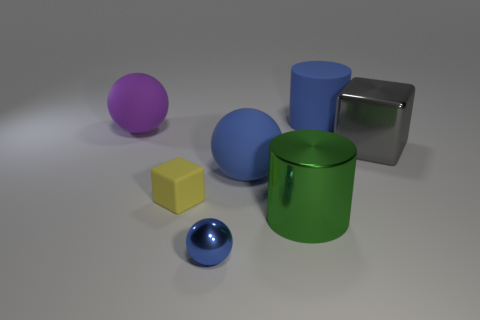Could you infer the function or purpose of each object depicted? The objects seem to be simplistic representations often used in visual or physical simulations and lack any specific features that would indicate a complex function. The green container and blue cylinder may serve as storage or vessels, potentially as simplified models of real-world items like cups or barrels. The balls and cube, due to their simple geometric shapes, could be placeholders or illustrative components in an educational context to demonstrate size, volume, or spatial concepts. 